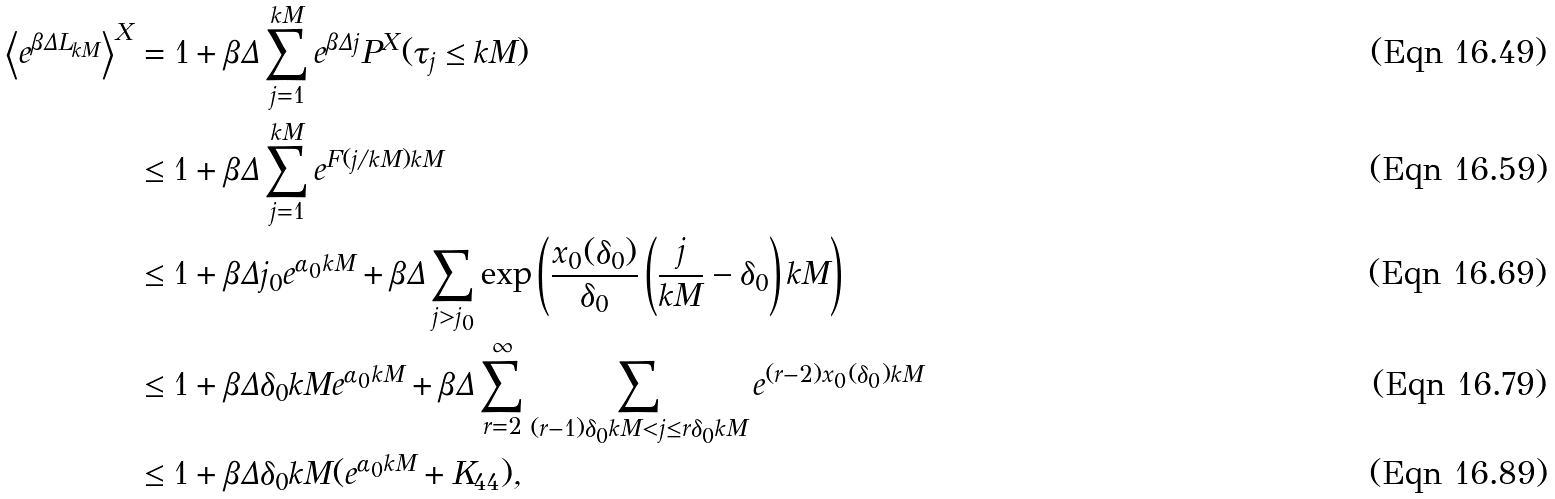<formula> <loc_0><loc_0><loc_500><loc_500>\left \langle e ^ { \beta \Delta L _ { k M } } \right \rangle ^ { X } & = 1 + \beta \Delta \sum _ { j = 1 } ^ { k M } e ^ { \beta \Delta j } P ^ { X } ( \tau _ { j } \leq k M ) \\ & \leq 1 + \beta \Delta \sum _ { j = 1 } ^ { k M } e ^ { F ( j / k M ) k M } \\ & \leq 1 + \beta \Delta j _ { 0 } e ^ { \alpha _ { 0 } k M } + \beta \Delta \sum _ { j > j _ { 0 } } \exp \left ( \frac { x _ { 0 } ( \delta _ { 0 } ) } { \delta _ { 0 } } \left ( \frac { j } { k M } - \delta _ { 0 } \right ) k M \right ) \\ & \leq 1 + \beta \Delta \delta _ { 0 } k M e ^ { \alpha _ { 0 } k M } + \beta \Delta \sum _ { r = 2 } ^ { \infty } \sum _ { ( r - 1 ) \delta _ { 0 } k M < j \leq r \delta _ { 0 } k M } e ^ { ( r - 2 ) x _ { 0 } ( \delta _ { 0 } ) k M } \\ & \leq 1 + \beta \Delta \delta _ { 0 } k M ( e ^ { \alpha _ { 0 } k M } + K _ { 4 4 } ) ,</formula> 